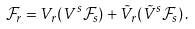<formula> <loc_0><loc_0><loc_500><loc_500>\mathcal { F } _ { r } = V _ { r } ( V ^ { s } \mathcal { F } _ { s } ) + \tilde { V } _ { r } ( \tilde { V } ^ { s } \mathcal { F } _ { s } ) \, .</formula> 